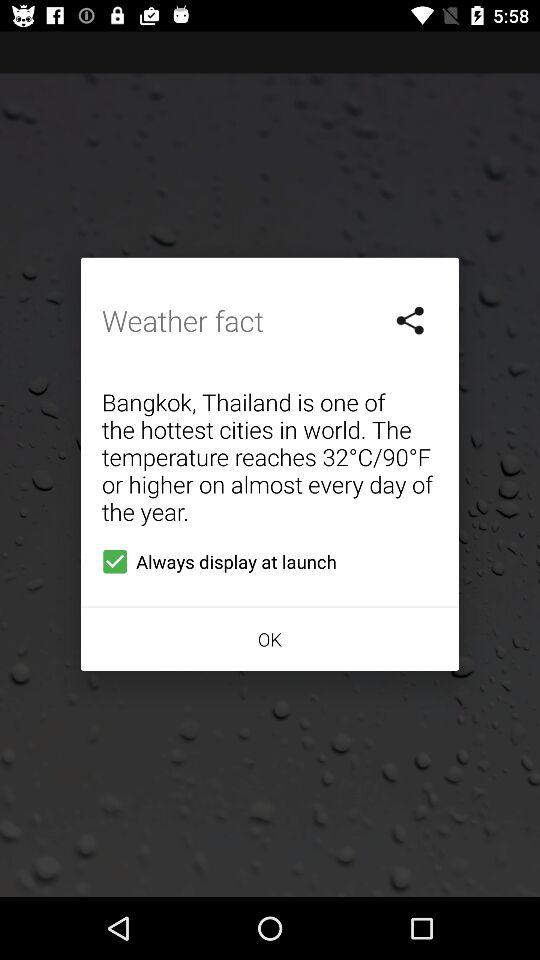What is the status of "Always display at launch"? The status is "on". 